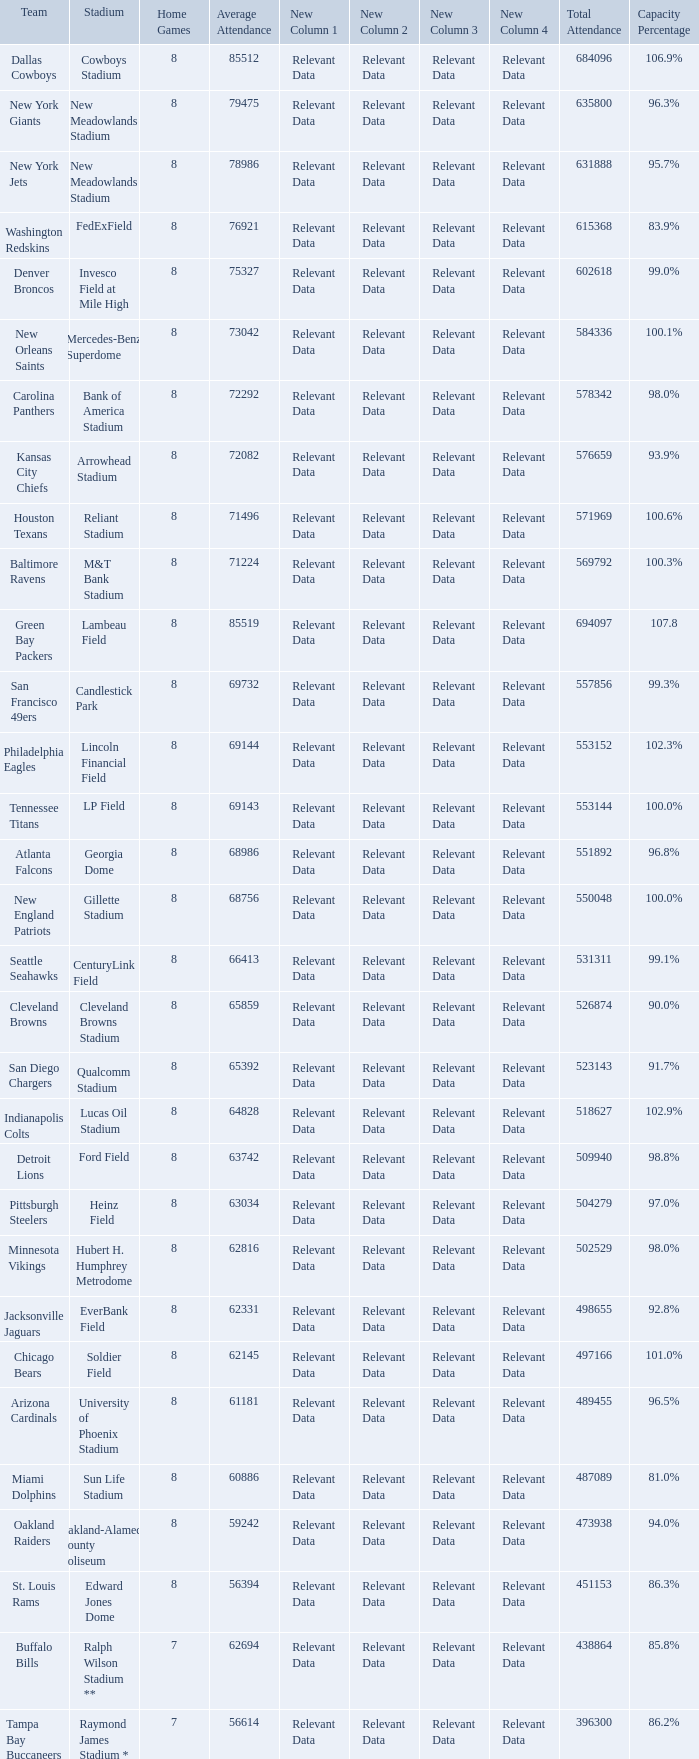What is the name of the team when the stadium is listed as Edward Jones Dome? St. Louis Rams. 